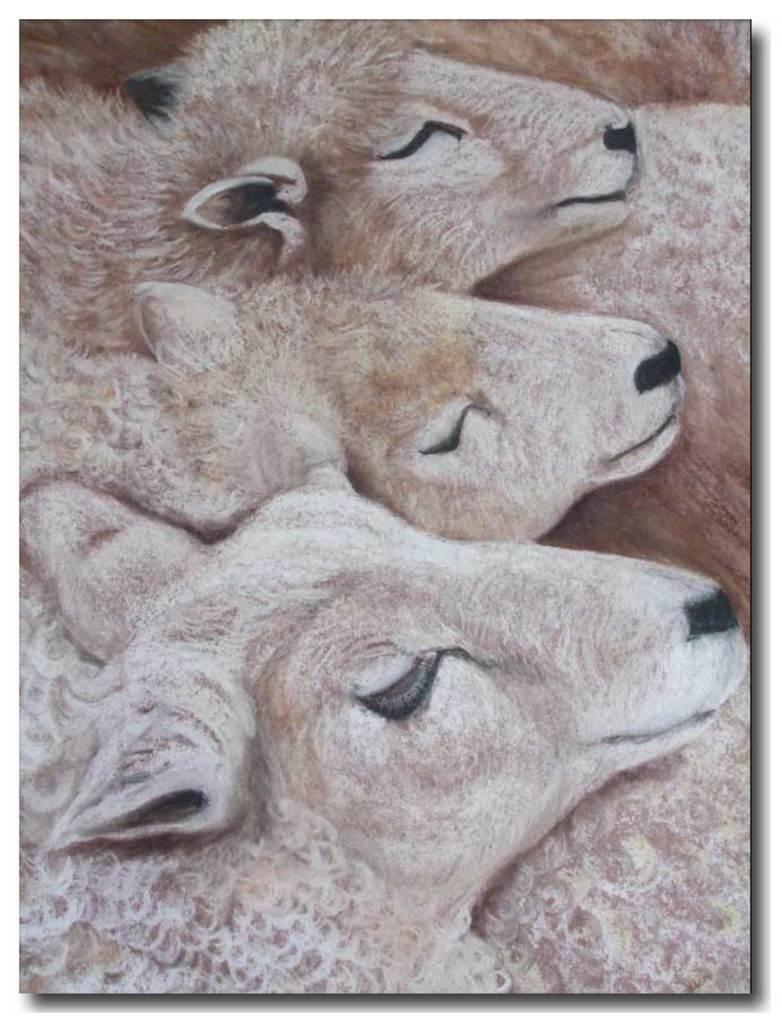In one or two sentences, can you explain what this image depicts? In this picture I can see painting of animals. 